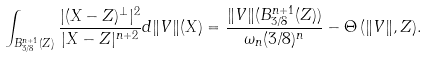Convert formula to latex. <formula><loc_0><loc_0><loc_500><loc_500>\int _ { B ^ { n + 1 } _ { 3 / 8 } ( Z ) } \frac { | ( X - Z ) ^ { \perp } | ^ { 2 } } { | X - Z | ^ { n + 2 } } d \| V \| ( X ) = \frac { \| V \| ( B _ { 3 / 8 } ^ { n + 1 } ( Z ) ) } { \omega _ { n } ( 3 / 8 ) ^ { n } } - \Theta \, ( \| V \| , Z ) .</formula> 